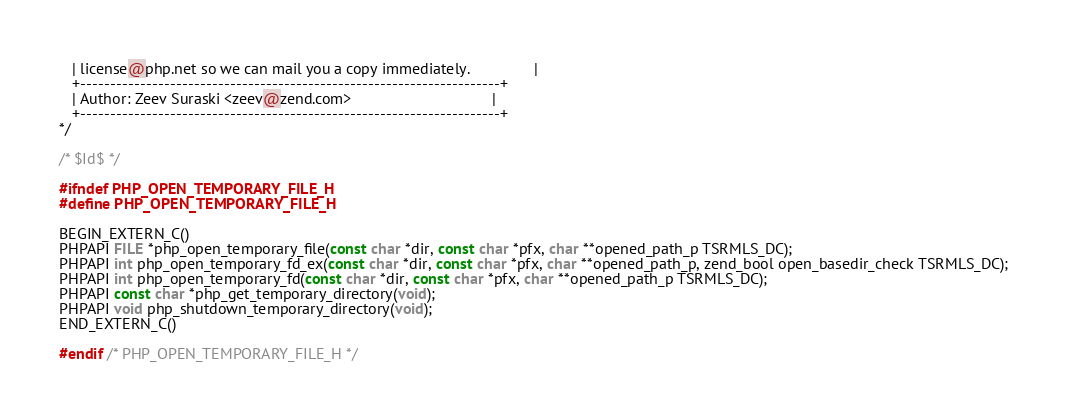Convert code to text. <code><loc_0><loc_0><loc_500><loc_500><_C_>   | license@php.net so we can mail you a copy immediately.               |
   +----------------------------------------------------------------------+
   | Author: Zeev Suraski <zeev@zend.com>                                 |
   +----------------------------------------------------------------------+
*/

/* $Id$ */

#ifndef PHP_OPEN_TEMPORARY_FILE_H
#define PHP_OPEN_TEMPORARY_FILE_H

BEGIN_EXTERN_C()
PHPAPI FILE *php_open_temporary_file(const char *dir, const char *pfx, char **opened_path_p TSRMLS_DC);
PHPAPI int php_open_temporary_fd_ex(const char *dir, const char *pfx, char **opened_path_p, zend_bool open_basedir_check TSRMLS_DC);
PHPAPI int php_open_temporary_fd(const char *dir, const char *pfx, char **opened_path_p TSRMLS_DC);
PHPAPI const char *php_get_temporary_directory(void);
PHPAPI void php_shutdown_temporary_directory(void);
END_EXTERN_C()

#endif /* PHP_OPEN_TEMPORARY_FILE_H */
</code> 